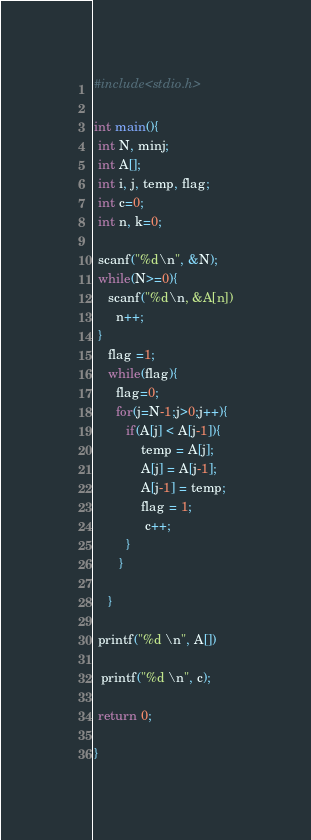Convert code to text. <code><loc_0><loc_0><loc_500><loc_500><_C_>#include<stdio.h>

int main(){
 int N, minj;
 int A[];
 int i, j, temp, flag;
 int c=0;
 int n, k=0;

 scanf("%d\n", &N);
 while(N>=0){
    scanf("%d\n, &A[n])
      n++;
 }
    flag =1;
    while(flag){
      flag=0;
      for(j=N-1;j>0;j++){
         if(A[j] < A[j-1]){
             temp = A[j];
             A[j] = A[j-1];
             A[j-1] = temp;
             flag = 1;
              c++;
         }
       }

    }

 printf("%d \n", A[])
 
  printf("%d \n", c);
 
 return 0;

}</code> 